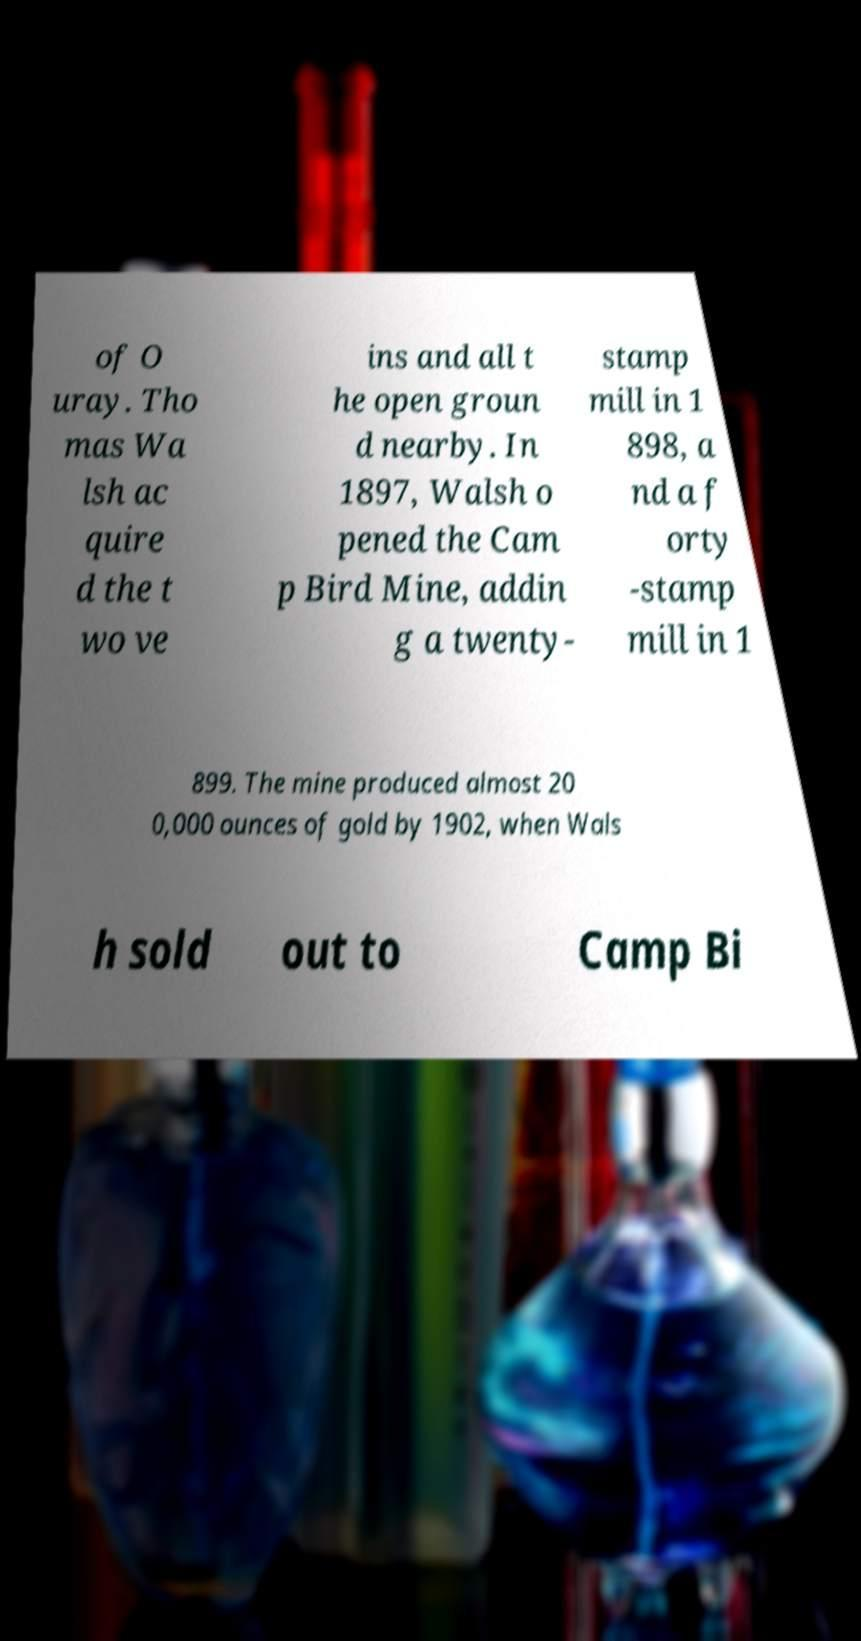What messages or text are displayed in this image? I need them in a readable, typed format. of O uray. Tho mas Wa lsh ac quire d the t wo ve ins and all t he open groun d nearby. In 1897, Walsh o pened the Cam p Bird Mine, addin g a twenty- stamp mill in 1 898, a nd a f orty -stamp mill in 1 899. The mine produced almost 20 0,000 ounces of gold by 1902, when Wals h sold out to Camp Bi 